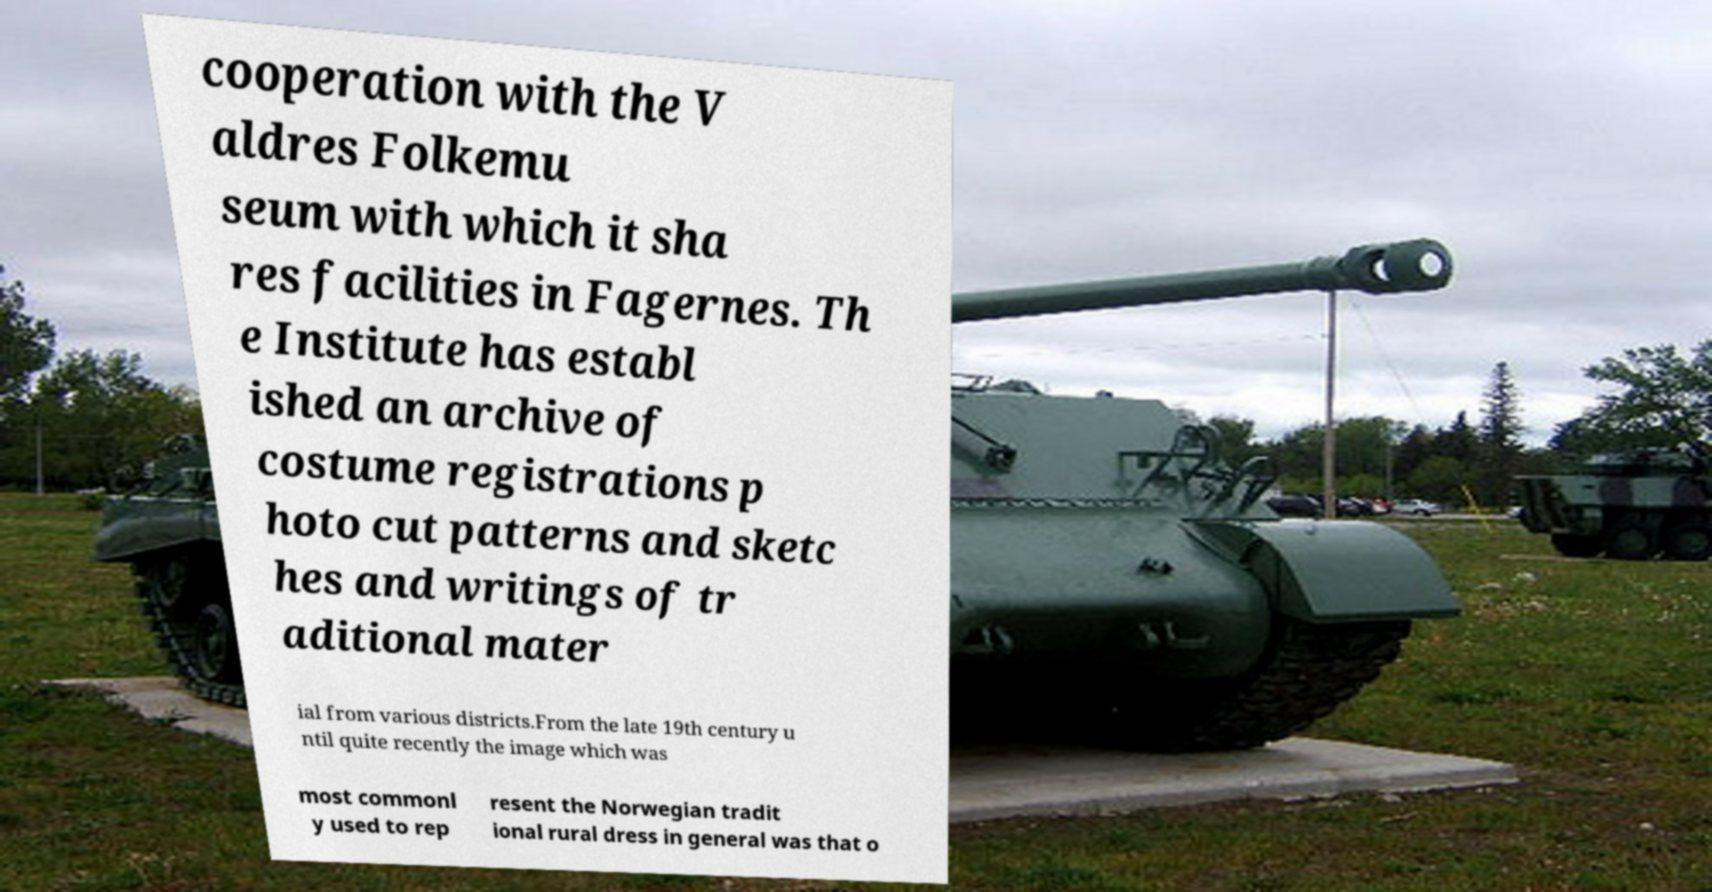For documentation purposes, I need the text within this image transcribed. Could you provide that? cooperation with the V aldres Folkemu seum with which it sha res facilities in Fagernes. Th e Institute has establ ished an archive of costume registrations p hoto cut patterns and sketc hes and writings of tr aditional mater ial from various districts.From the late 19th century u ntil quite recently the image which was most commonl y used to rep resent the Norwegian tradit ional rural dress in general was that o 